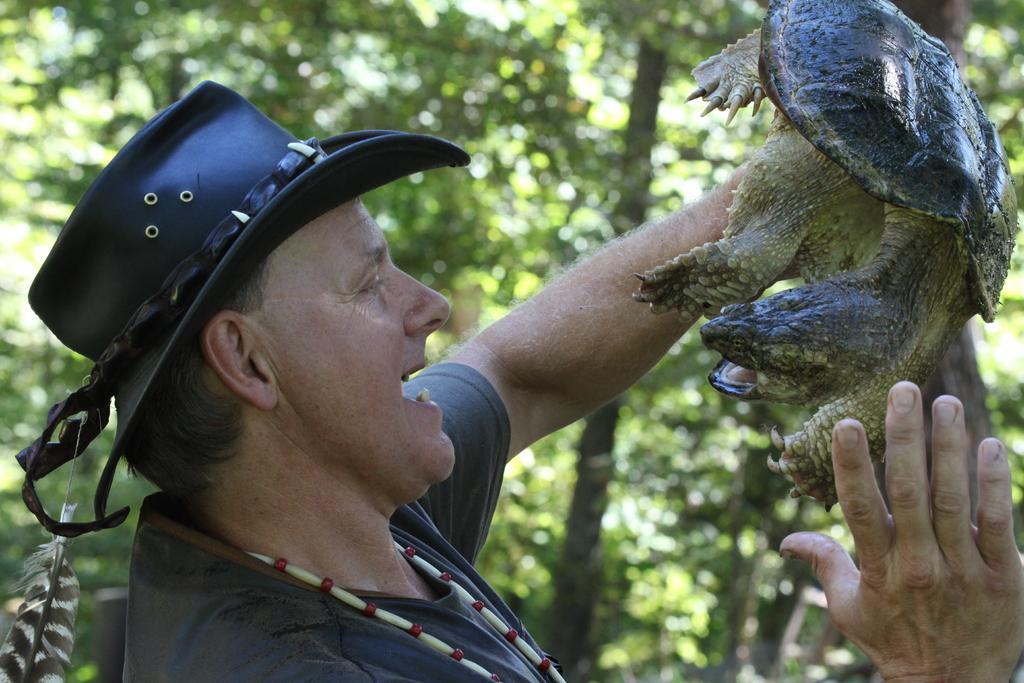How would you summarize this image in a sentence or two? In the image we can see there is a man standing and he is holding a tortoise in his hand. He is wearing cap and behind there are trees and the image is little blurry at the back. 